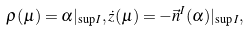<formula> <loc_0><loc_0><loc_500><loc_500>\rho ( \mu ) = \alpha | _ { \sup I } , \dot { z } ( \mu ) = - \vec { n } ^ { I } ( \alpha ) | _ { \sup I } ,</formula> 